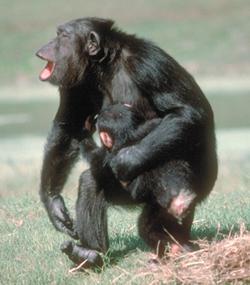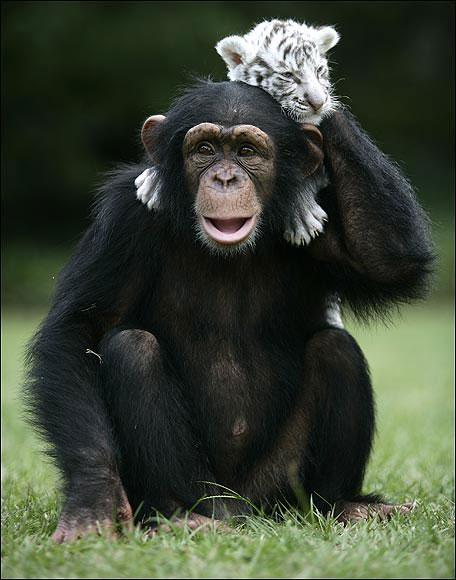The first image is the image on the left, the second image is the image on the right. Evaluate the accuracy of this statement regarding the images: "The animal in the image on the left has its back to a tree.". Is it true? Answer yes or no. No. The first image is the image on the left, the second image is the image on the right. Given the left and right images, does the statement "The left image features exactly one chimpanzee." hold true? Answer yes or no. No. 